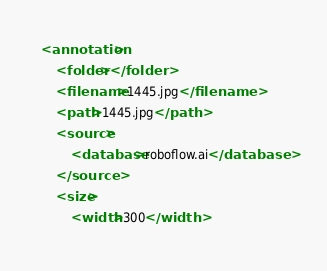<code> <loc_0><loc_0><loc_500><loc_500><_XML_><annotation>
	<folder></folder>
	<filename>1445.jpg</filename>
	<path>1445.jpg</path>
	<source>
		<database>roboflow.ai</database>
	</source>
	<size>
		<width>300</width></code> 